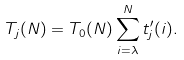Convert formula to latex. <formula><loc_0><loc_0><loc_500><loc_500>T _ { j } ( N ) = T _ { 0 } ( N ) \sum _ { i = \lambda } ^ { N } t ^ { \prime } _ { j } ( i ) .</formula> 